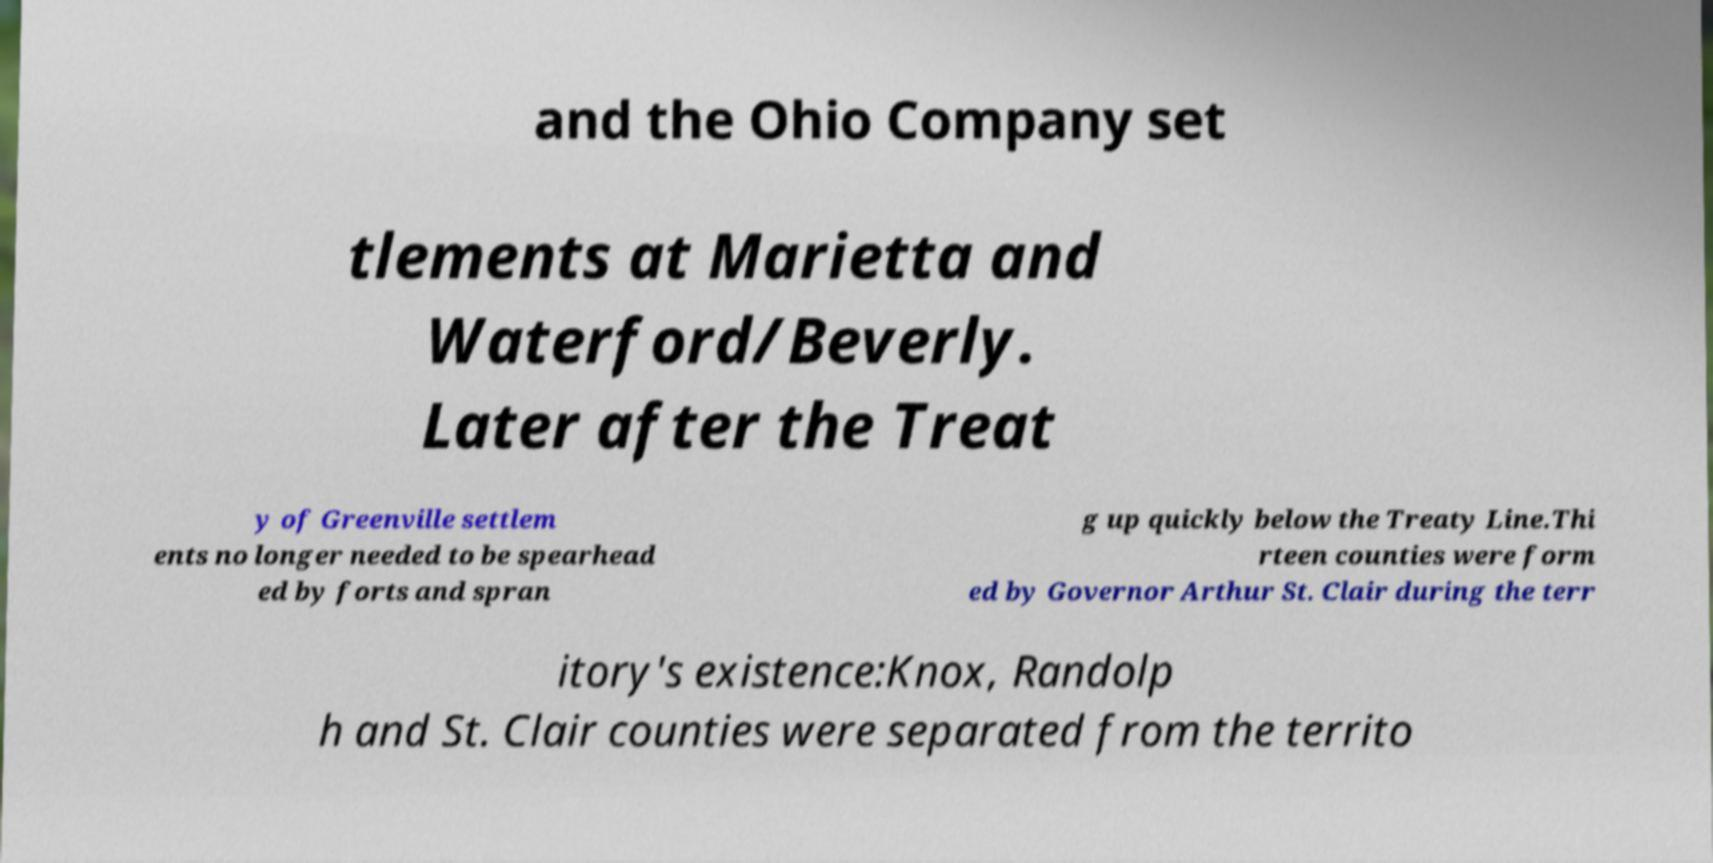Can you read and provide the text displayed in the image?This photo seems to have some interesting text. Can you extract and type it out for me? and the Ohio Company set tlements at Marietta and Waterford/Beverly. Later after the Treat y of Greenville settlem ents no longer needed to be spearhead ed by forts and spran g up quickly below the Treaty Line.Thi rteen counties were form ed by Governor Arthur St. Clair during the terr itory's existence:Knox, Randolp h and St. Clair counties were separated from the territo 